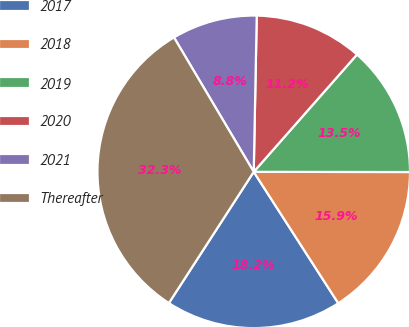Convert chart. <chart><loc_0><loc_0><loc_500><loc_500><pie_chart><fcel>2017<fcel>2018<fcel>2019<fcel>2020<fcel>2021<fcel>Thereafter<nl><fcel>18.23%<fcel>15.88%<fcel>13.53%<fcel>11.18%<fcel>8.83%<fcel>32.34%<nl></chart> 